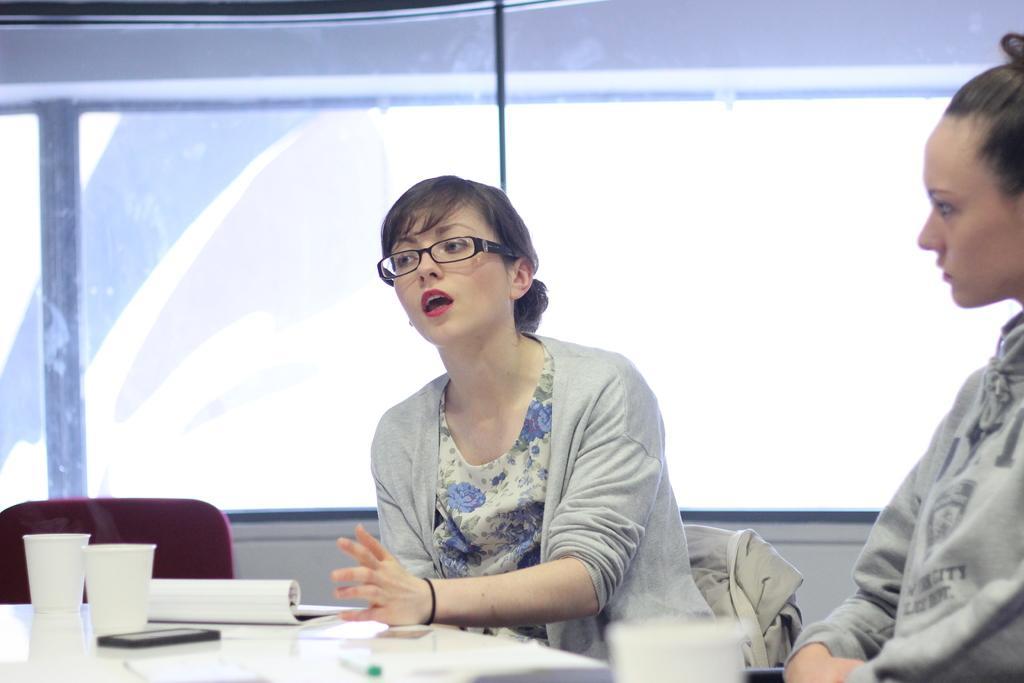In one or two sentences, can you explain what this image depicts? In this image, there are two persons sitting on the chairs. At the bottom of the image, I can see the cups, a book, mobile and few other things on a table. In the background, I can see a glass window. 